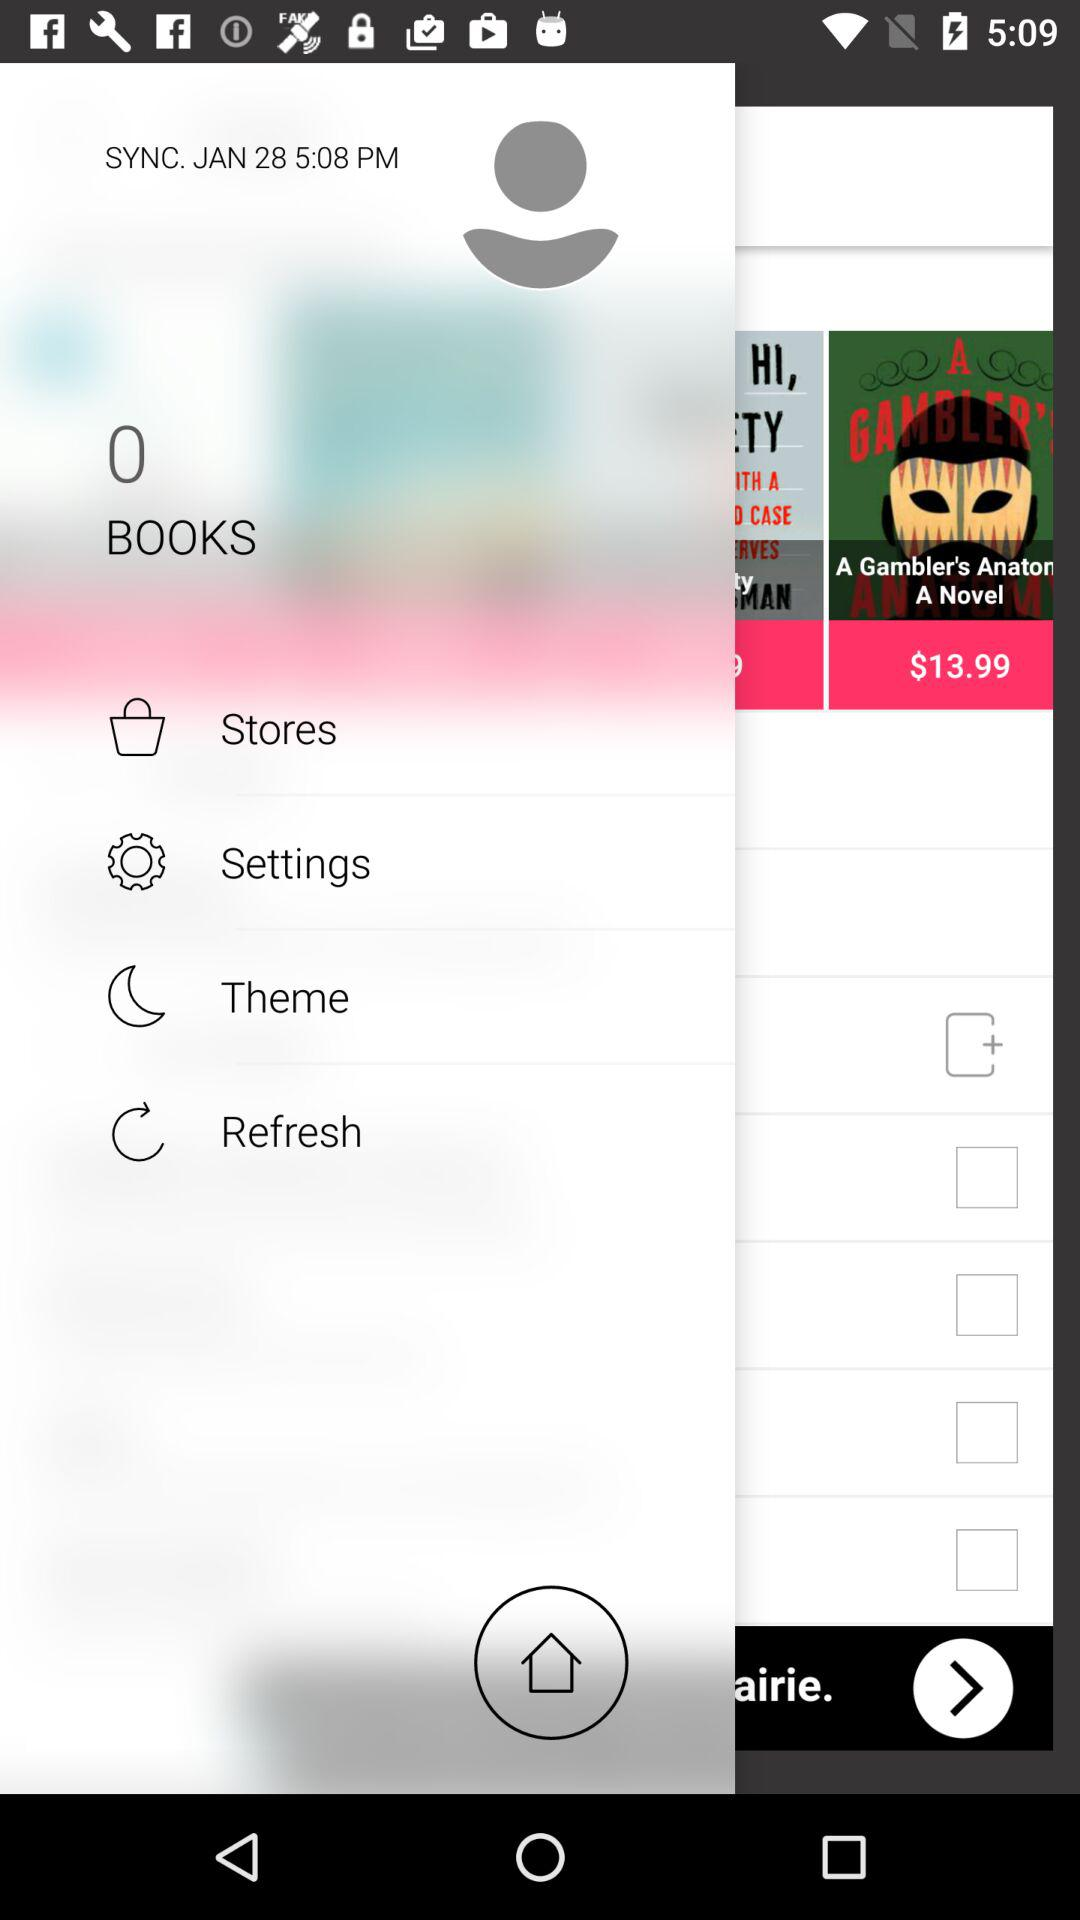What is the number of books shown in the application? The number of books shown in the application is 0. 